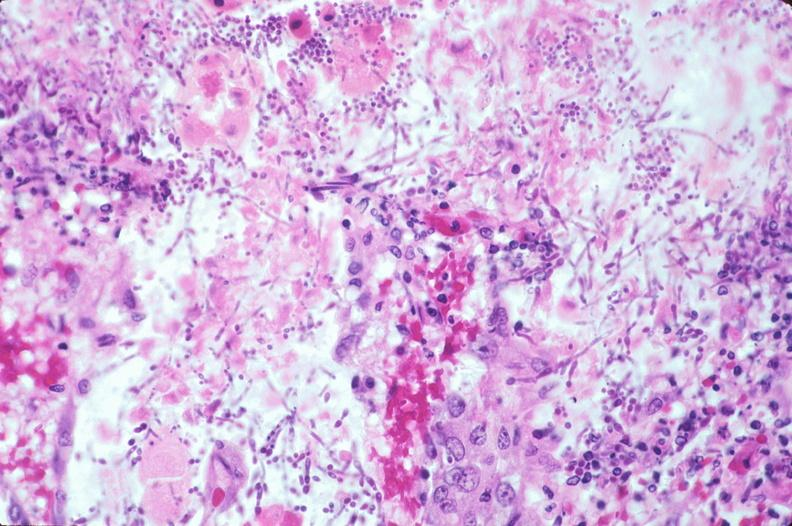s gastrointestinal present?
Answer the question using a single word or phrase. Yes 